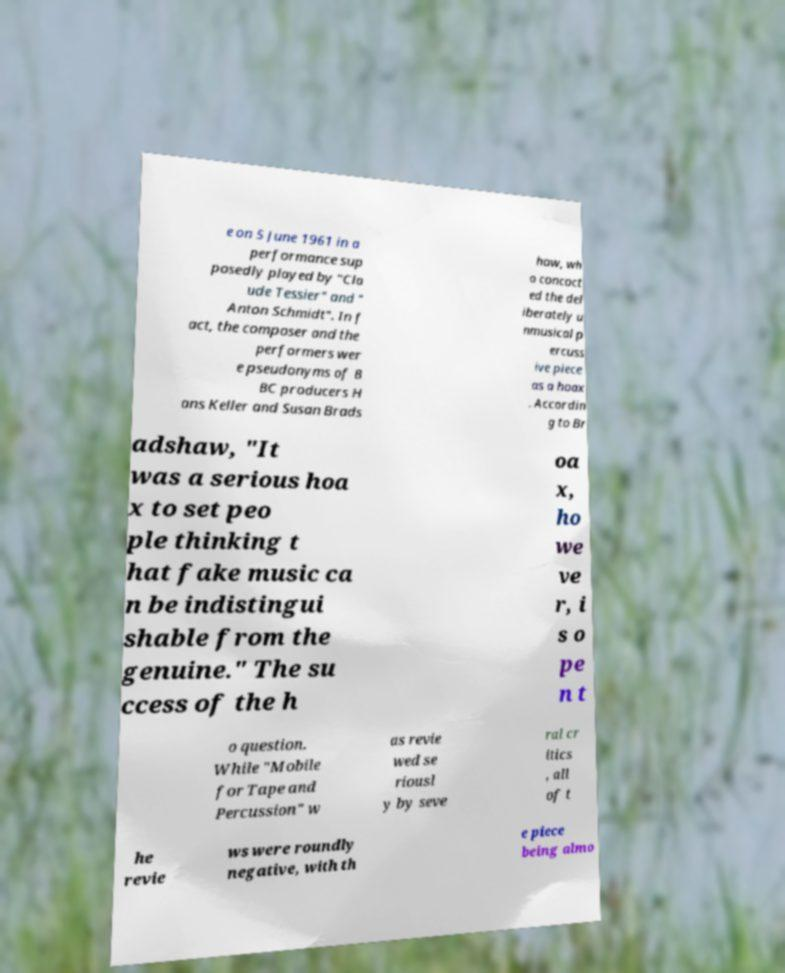Please identify and transcribe the text found in this image. e on 5 June 1961 in a performance sup posedly played by "Cla ude Tessier" and " Anton Schmidt". In f act, the composer and the performers wer e pseudonyms of B BC producers H ans Keller and Susan Brads haw, wh o concoct ed the del iberately u nmusical p ercuss ive piece as a hoax . Accordin g to Br adshaw, "It was a serious hoa x to set peo ple thinking t hat fake music ca n be indistingui shable from the genuine." The su ccess of the h oa x, ho we ve r, i s o pe n t o question. While "Mobile for Tape and Percussion" w as revie wed se riousl y by seve ral cr itics , all of t he revie ws were roundly negative, with th e piece being almo 